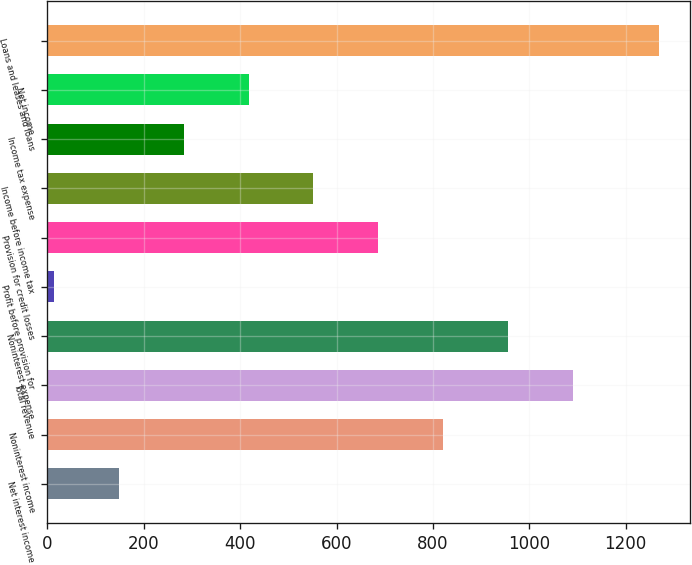Convert chart. <chart><loc_0><loc_0><loc_500><loc_500><bar_chart><fcel>Net interest income<fcel>Noninterest income<fcel>Total revenue<fcel>Noninterest expense<fcel>Profit before provision for<fcel>Provision for credit losses<fcel>Income before income tax<fcel>Income tax expense<fcel>Net income<fcel>Loans and leases and loans<nl><fcel>148.5<fcel>821<fcel>1090<fcel>955.5<fcel>14<fcel>686.5<fcel>552<fcel>283<fcel>417.5<fcel>1270<nl></chart> 